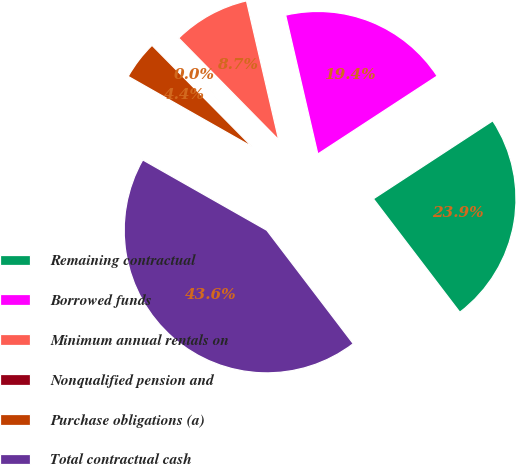<chart> <loc_0><loc_0><loc_500><loc_500><pie_chart><fcel>Remaining contractual<fcel>Borrowed funds<fcel>Minimum annual rentals on<fcel>Nonqualified pension and<fcel>Purchase obligations (a)<fcel>Total contractual cash<nl><fcel>23.85%<fcel>19.41%<fcel>8.74%<fcel>0.03%<fcel>4.39%<fcel>43.58%<nl></chart> 